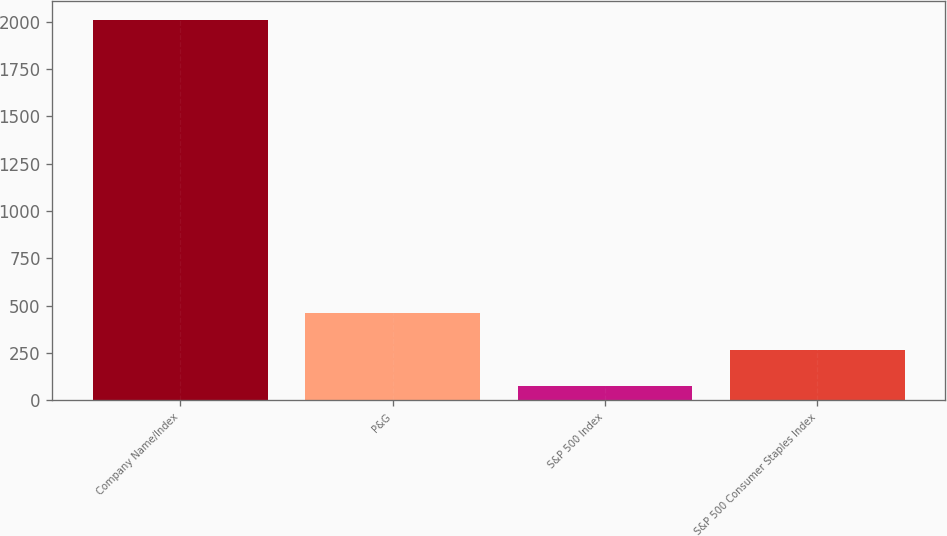Convert chart to OTSL. <chart><loc_0><loc_0><loc_500><loc_500><bar_chart><fcel>Company Name/Index<fcel>P&G<fcel>S&P 500 Index<fcel>S&P 500 Consumer Staples Index<nl><fcel>2010<fcel>460.4<fcel>73<fcel>266.7<nl></chart> 